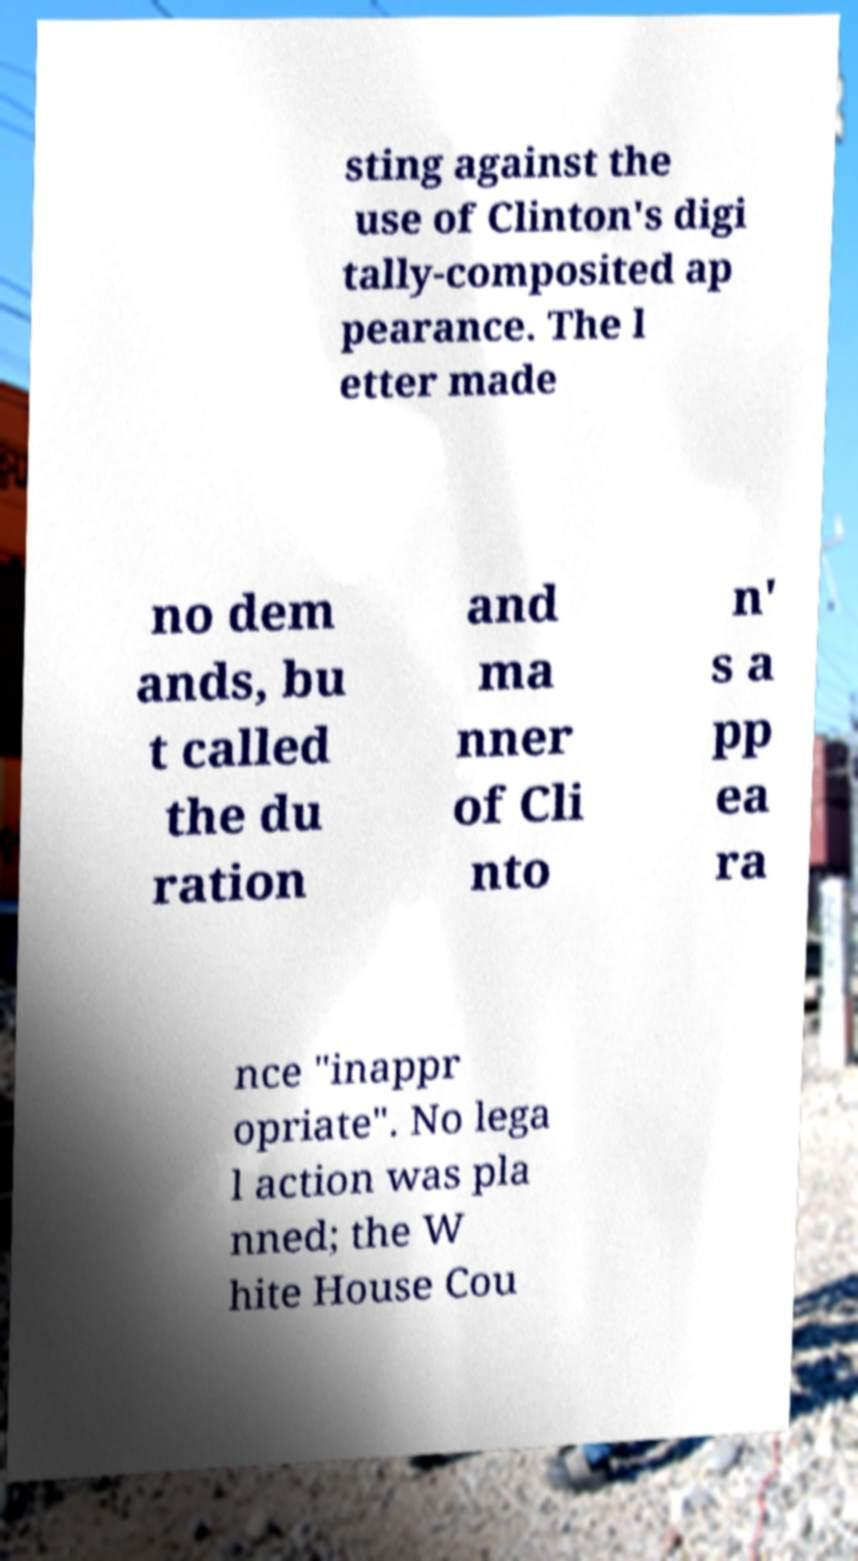I need the written content from this picture converted into text. Can you do that? sting against the use of Clinton's digi tally-composited ap pearance. The l etter made no dem ands, bu t called the du ration and ma nner of Cli nto n' s a pp ea ra nce "inappr opriate". No lega l action was pla nned; the W hite House Cou 